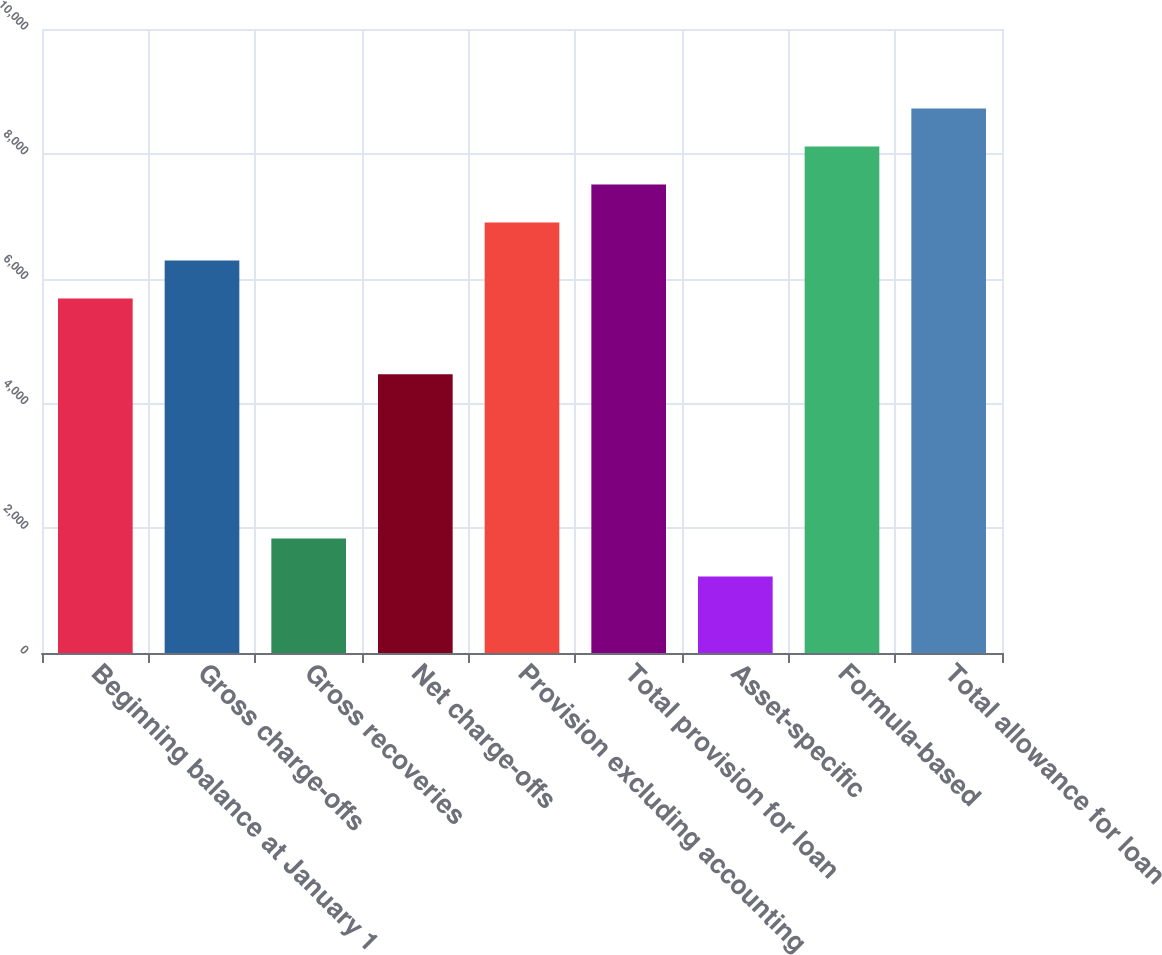<chart> <loc_0><loc_0><loc_500><loc_500><bar_chart><fcel>Beginning balance at January 1<fcel>Gross charge-offs<fcel>Gross recoveries<fcel>Net charge-offs<fcel>Provision excluding accounting<fcel>Total provision for loan<fcel>Asset-specific<fcel>Formula-based<fcel>Total allowance for loan<nl><fcel>5683<fcel>6291.5<fcel>1835.5<fcel>4466<fcel>6900<fcel>7508.5<fcel>1227<fcel>8117<fcel>8725.5<nl></chart> 